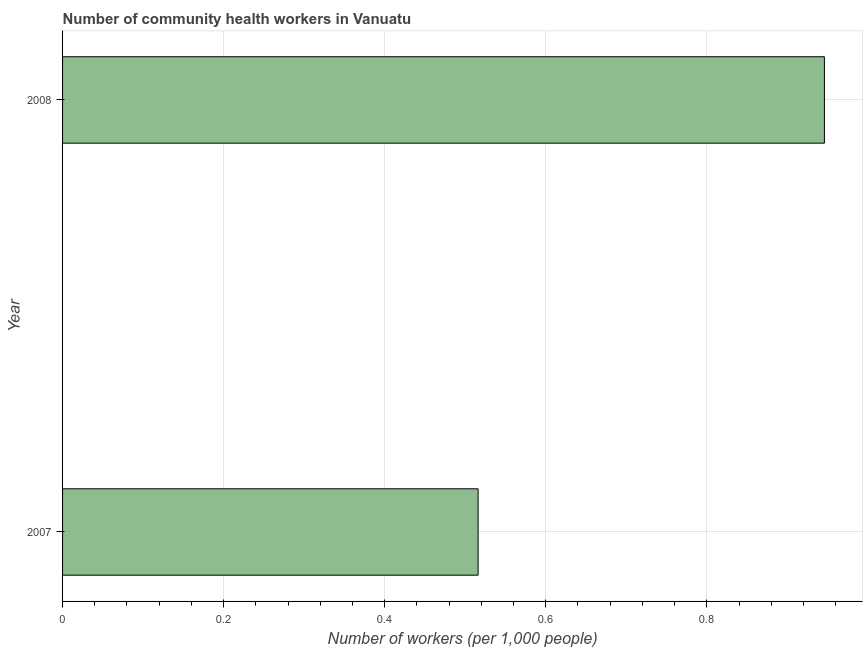What is the title of the graph?
Your answer should be very brief. Number of community health workers in Vanuatu. What is the label or title of the X-axis?
Provide a succinct answer. Number of workers (per 1,0 people). What is the number of community health workers in 2007?
Provide a succinct answer. 0.52. Across all years, what is the maximum number of community health workers?
Ensure brevity in your answer.  0.95. Across all years, what is the minimum number of community health workers?
Offer a very short reply. 0.52. In which year was the number of community health workers maximum?
Provide a short and direct response. 2008. What is the sum of the number of community health workers?
Offer a terse response. 1.46. What is the difference between the number of community health workers in 2007 and 2008?
Provide a succinct answer. -0.43. What is the average number of community health workers per year?
Your answer should be very brief. 0.73. What is the median number of community health workers?
Offer a terse response. 0.73. In how many years, is the number of community health workers greater than 0.52 ?
Give a very brief answer. 1. Do a majority of the years between 2008 and 2007 (inclusive) have number of community health workers greater than 0.2 ?
Offer a very short reply. No. What is the ratio of the number of community health workers in 2007 to that in 2008?
Make the answer very short. 0.55. Is the number of community health workers in 2007 less than that in 2008?
Provide a short and direct response. Yes. How many bars are there?
Provide a succinct answer. 2. How many years are there in the graph?
Make the answer very short. 2. Are the values on the major ticks of X-axis written in scientific E-notation?
Offer a terse response. No. What is the Number of workers (per 1,000 people) of 2007?
Your answer should be compact. 0.52. What is the Number of workers (per 1,000 people) in 2008?
Ensure brevity in your answer.  0.95. What is the difference between the Number of workers (per 1,000 people) in 2007 and 2008?
Give a very brief answer. -0.43. What is the ratio of the Number of workers (per 1,000 people) in 2007 to that in 2008?
Give a very brief answer. 0.55. 